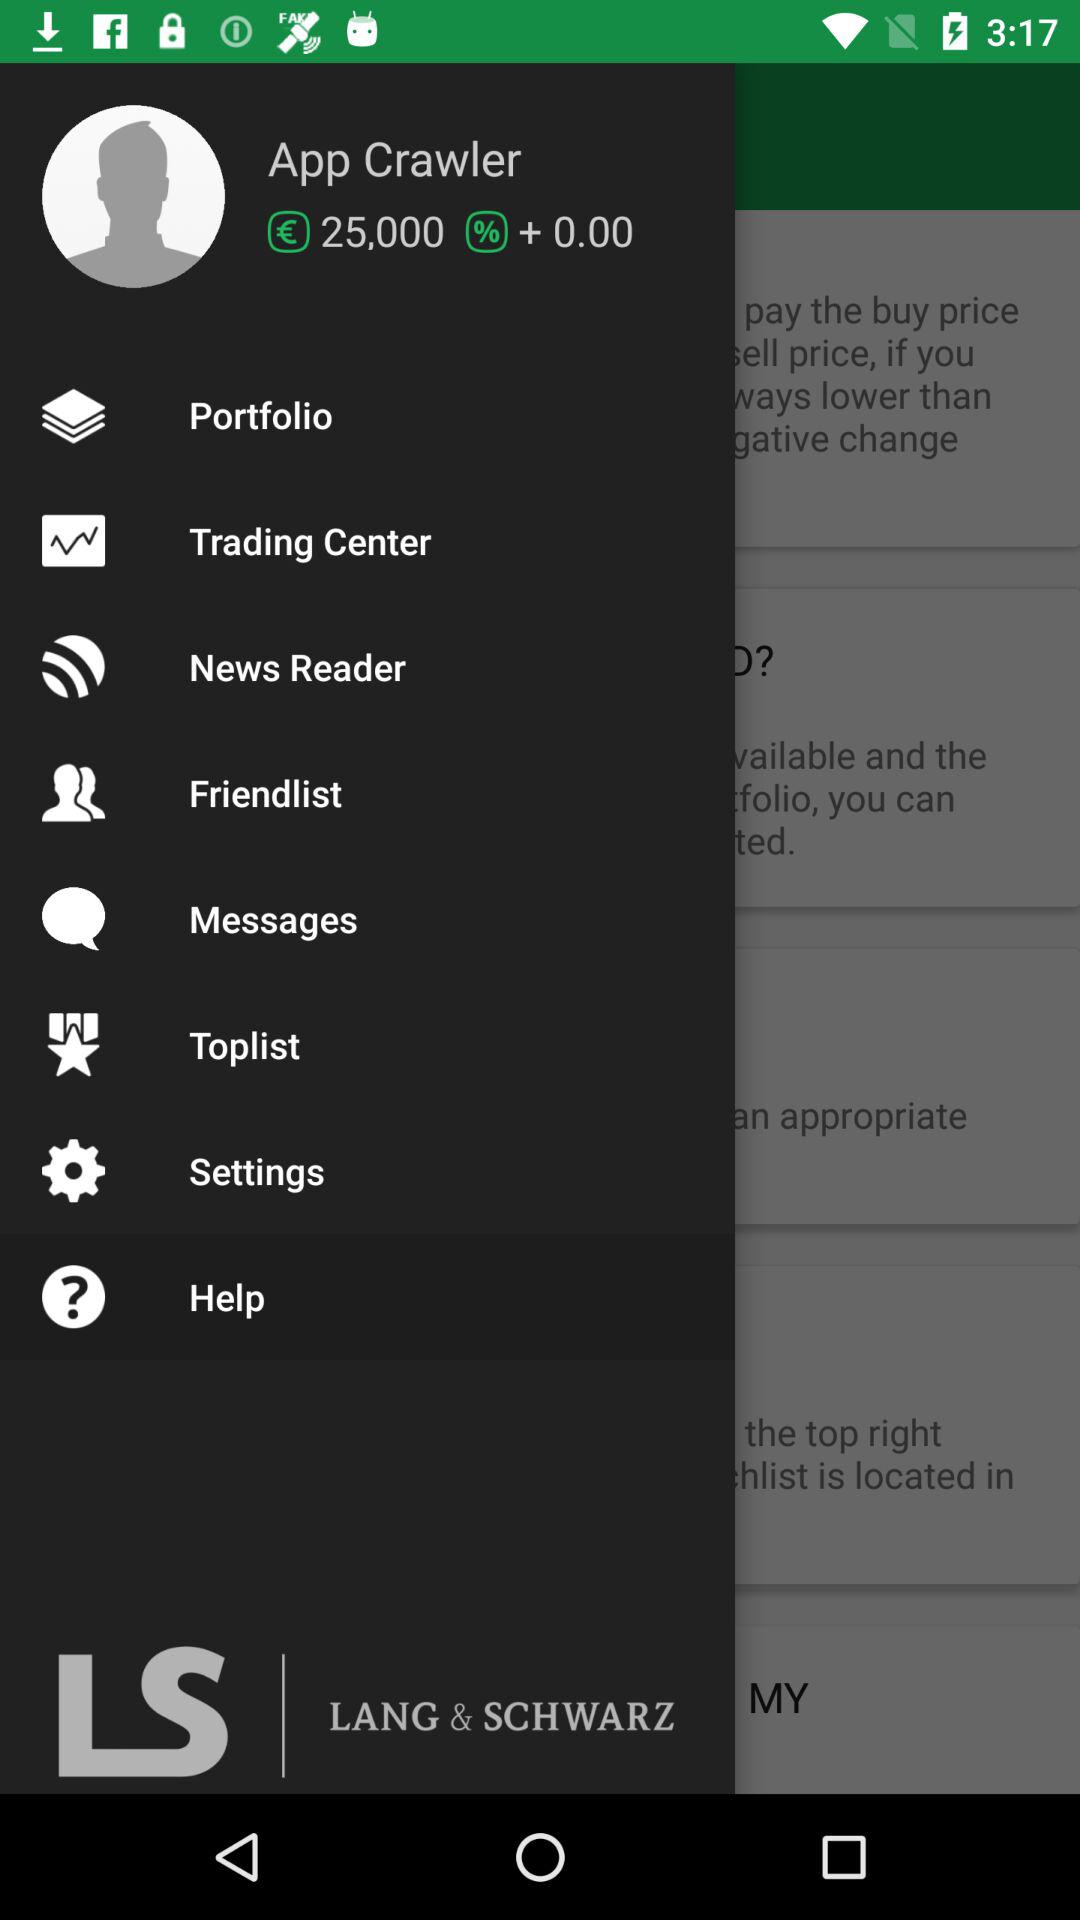What is the user name? The user name is App Crawler. 